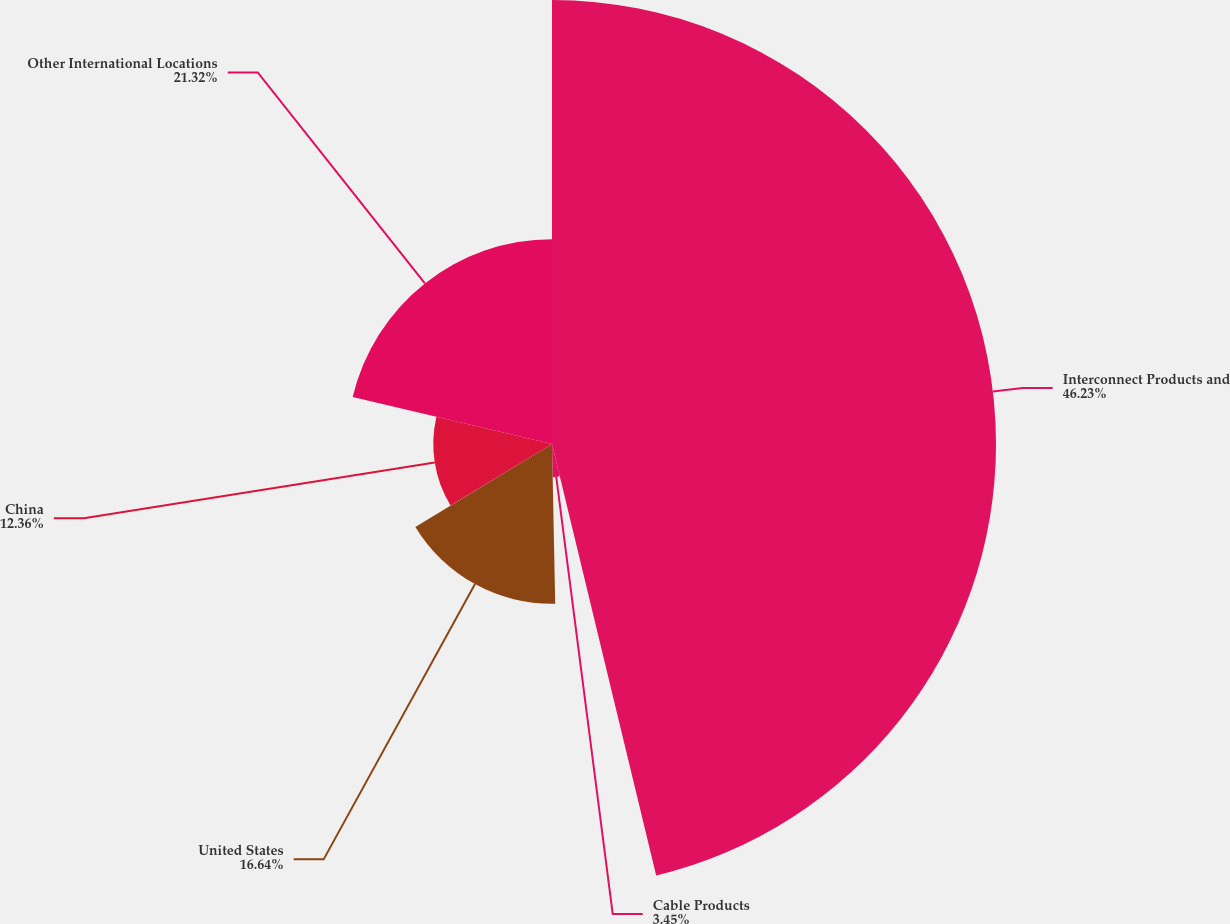Convert chart to OTSL. <chart><loc_0><loc_0><loc_500><loc_500><pie_chart><fcel>Interconnect Products and<fcel>Cable Products<fcel>United States<fcel>China<fcel>Other International Locations<nl><fcel>46.23%<fcel>3.45%<fcel>16.64%<fcel>12.36%<fcel>21.32%<nl></chart> 